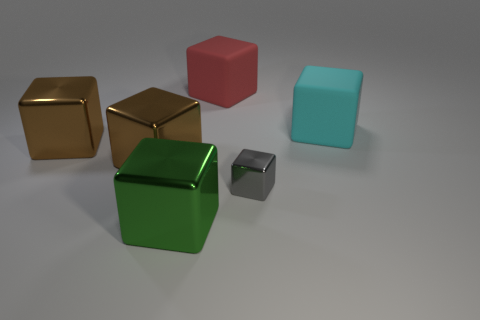Subtract all green cubes. How many cubes are left? 5 Subtract all small gray blocks. How many blocks are left? 5 Subtract all purple blocks. Subtract all brown spheres. How many blocks are left? 6 Add 2 big gray metallic objects. How many objects exist? 8 Add 3 shiny objects. How many shiny objects exist? 7 Subtract 0 purple balls. How many objects are left? 6 Subtract all big brown metal cubes. Subtract all red objects. How many objects are left? 3 Add 5 red blocks. How many red blocks are left? 6 